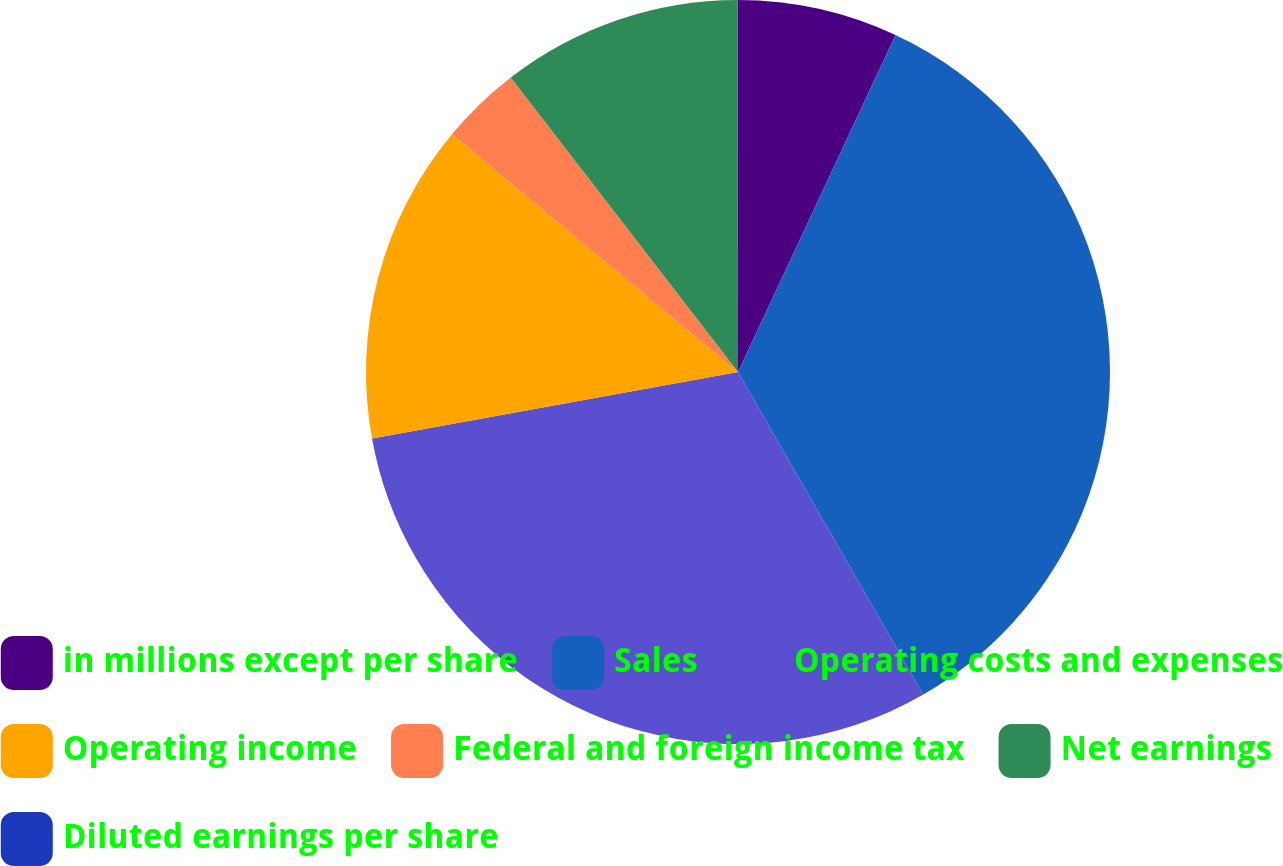Convert chart to OTSL. <chart><loc_0><loc_0><loc_500><loc_500><pie_chart><fcel>in millions except per share<fcel>Sales<fcel>Operating costs and expenses<fcel>Operating income<fcel>Federal and foreign income tax<fcel>Net earnings<fcel>Diluted earnings per share<nl><fcel>6.96%<fcel>34.74%<fcel>30.44%<fcel>13.91%<fcel>3.49%<fcel>10.44%<fcel>0.02%<nl></chart> 